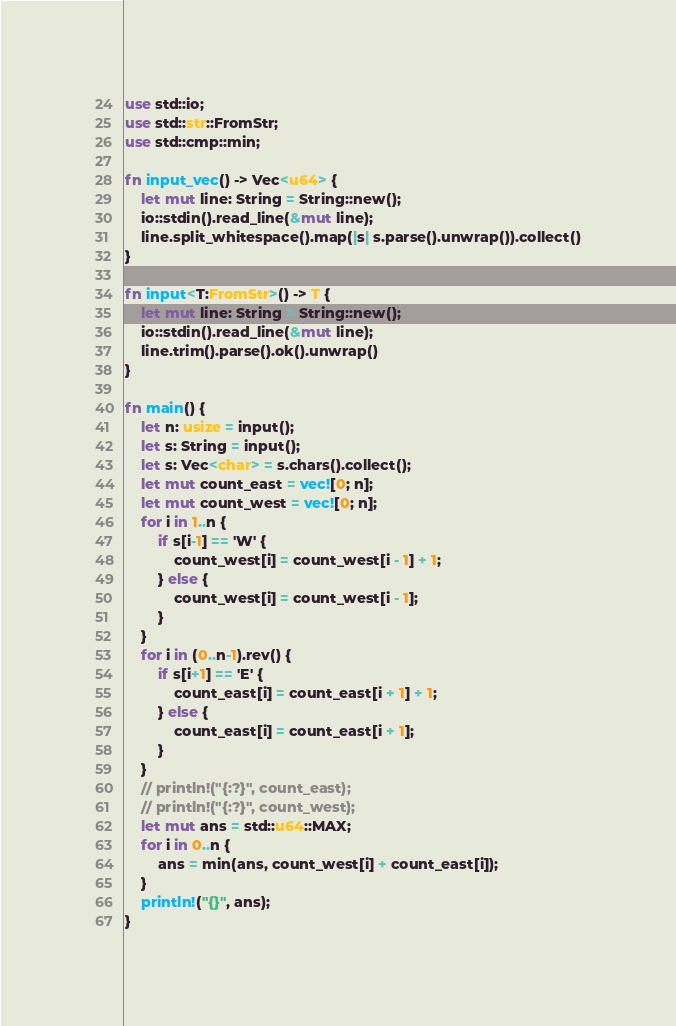<code> <loc_0><loc_0><loc_500><loc_500><_Rust_>use std::io;
use std::str::FromStr;
use std::cmp::min;

fn input_vec() -> Vec<u64> {
    let mut line: String = String::new();
    io::stdin().read_line(&mut line);
    line.split_whitespace().map(|s| s.parse().unwrap()).collect()
}

fn input<T:FromStr>() -> T {
    let mut line: String = String::new();
    io::stdin().read_line(&mut line);
    line.trim().parse().ok().unwrap()
}

fn main() {
    let n: usize = input();
    let s: String = input();
    let s: Vec<char> = s.chars().collect();
    let mut count_east = vec![0; n];
    let mut count_west = vec![0; n];
    for i in 1..n {
        if s[i-1] == 'W' {
            count_west[i] = count_west[i - 1] + 1;
        } else {
            count_west[i] = count_west[i - 1];
        }
    }
    for i in (0..n-1).rev() {
        if s[i+1] == 'E' {
            count_east[i] = count_east[i + 1] + 1;
        } else {
            count_east[i] = count_east[i + 1];
        }
    }
    // println!("{:?}", count_east);
    // println!("{:?}", count_west);
    let mut ans = std::u64::MAX;
    for i in 0..n {
        ans = min(ans, count_west[i] + count_east[i]);
    }
    println!("{}", ans);
}
</code> 